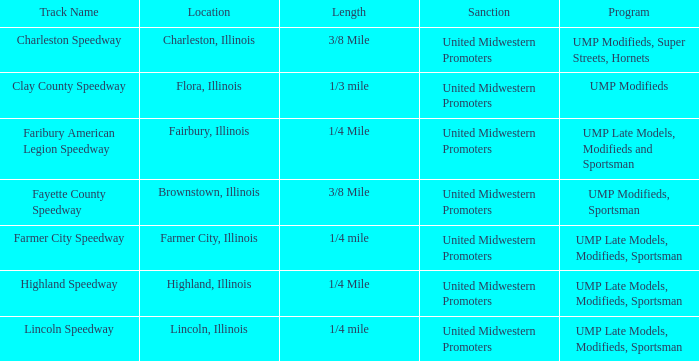What programs were held in charleston, illinois? UMP Modifieds, Super Streets, Hornets. Would you mind parsing the complete table? {'header': ['Track Name', 'Location', 'Length', 'Sanction', 'Program'], 'rows': [['Charleston Speedway', 'Charleston, Illinois', '3/8 Mile', 'United Midwestern Promoters', 'UMP Modifieds, Super Streets, Hornets'], ['Clay County Speedway', 'Flora, Illinois', '1/3 mile', 'United Midwestern Promoters', 'UMP Modifieds'], ['Faribury American Legion Speedway', 'Fairbury, Illinois', '1/4 Mile', 'United Midwestern Promoters', 'UMP Late Models, Modifieds and Sportsman'], ['Fayette County Speedway', 'Brownstown, Illinois', '3/8 Mile', 'United Midwestern Promoters', 'UMP Modifieds, Sportsman'], ['Farmer City Speedway', 'Farmer City, Illinois', '1/4 mile', 'United Midwestern Promoters', 'UMP Late Models, Modifieds, Sportsman'], ['Highland Speedway', 'Highland, Illinois', '1/4 Mile', 'United Midwestern Promoters', 'UMP Late Models, Modifieds, Sportsman'], ['Lincoln Speedway', 'Lincoln, Illinois', '1/4 mile', 'United Midwestern Promoters', 'UMP Late Models, Modifieds, Sportsman']]} 